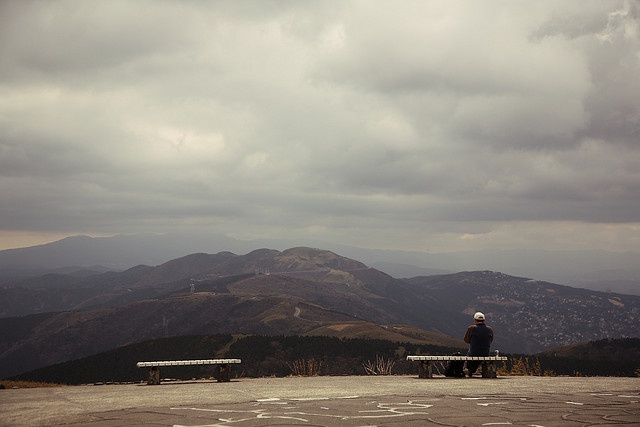Describe the objects in this image and their specific colors. I can see bench in gray, black, and tan tones, people in gray, black, maroon, and darkgray tones, bench in gray, black, tan, and beige tones, and dog in gray, black, and maroon tones in this image. 